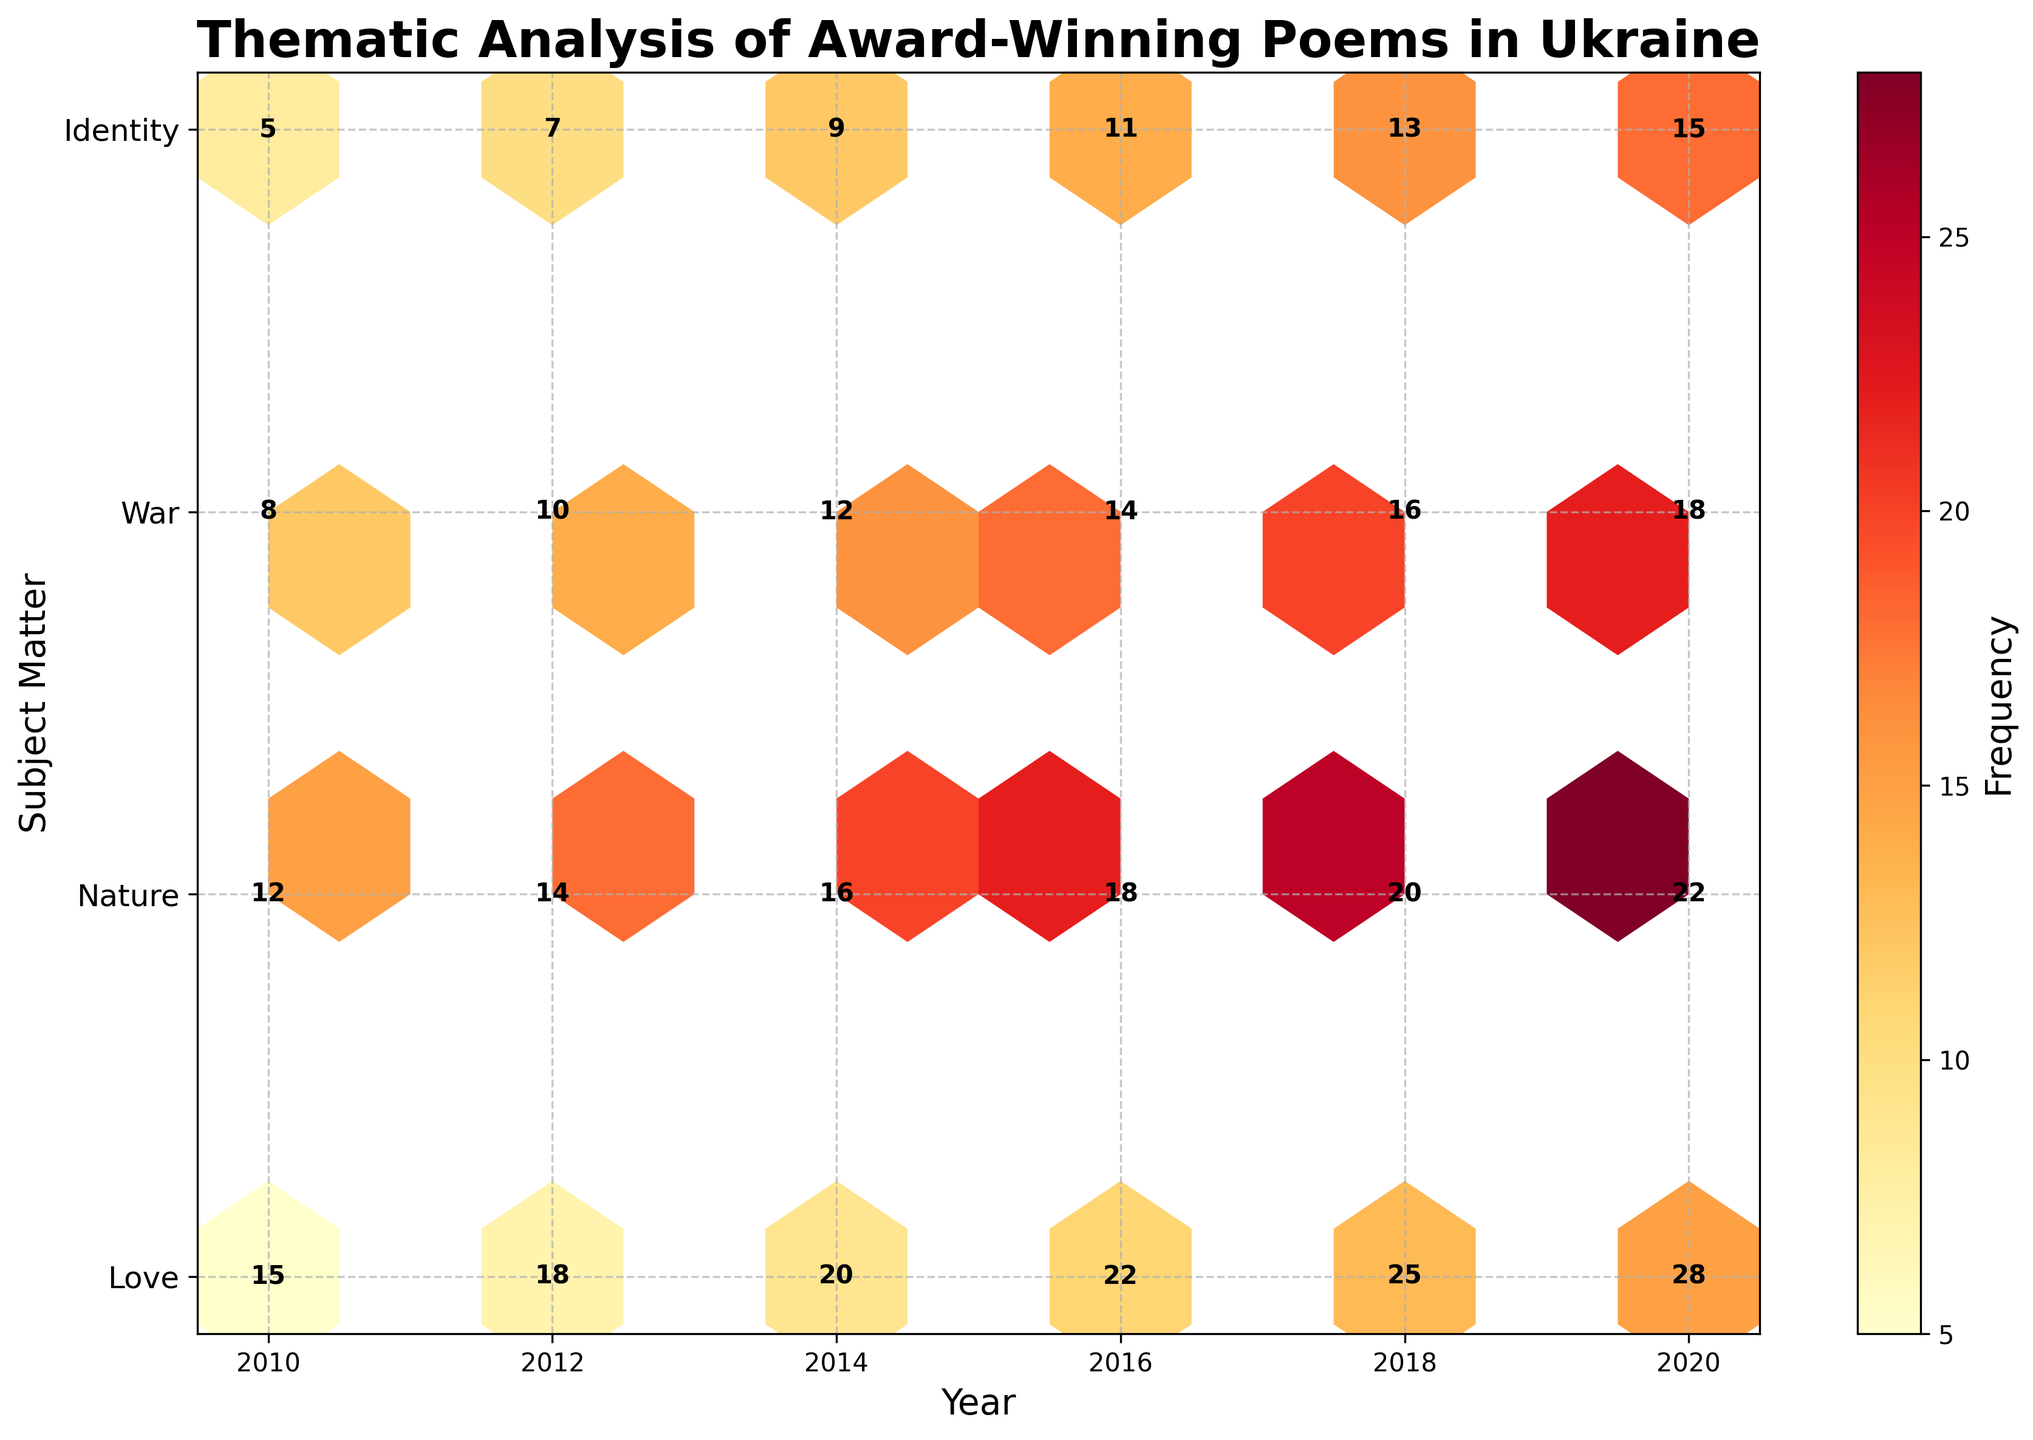What is the title of the plot? The title of the plot can be seen at the top of the figure. It reads "Thematic Analysis of Award-Winning Poems in Ukraine".
Answer: Thematic Analysis of Award-Winning Poems in Ukraine What years are represented on the X-axis? By examining the X-axis, you can see the labels for different years. The plot includes years 2010, 2012, 2014, 2016, 2018, and 2020.
Answer: 2010, 2012, 2014, 2016, 2018, 2020 How is the frequency of each subject indicated? The frequency is indicated by both color intensity and the number annotations on each hexbin. The color ranges from lighter to darker shades of yellow, orange, and red as frequency increases.
Answer: Color intensity and number annotations Which subject had the highest frequency in the year 2020? To find the highest frequency in 2020, look at the year 2020 on the X-axis and check the frequencies annotated in that column. The subject "Love" has the highest frequency of 28 in 2020.
Answer: Love How does the frequency of "Nature" change from 2010 to 2020? By examining the hexbin plot along the row corresponding to "Nature," note the frequencies annotated for each year. The frequencies are 12 (2010), 14 (2012), 16 (2014), 18 (2016), 20 (2018), and 22 (2020). Frequency increases by 2 every 2 years.
Answer: Increases steadily What is the combined frequency of the "War" subject for all the years represented? Summing up the frequencies of "War" for all years: 8 (2010) + 10 (2012) + 12 (2014) + 14 (2016) + 16 (2018) + 18 (2020) = 78.
Answer: 78 Compare the frequency trends of "Love" and "Identity" from 2010 to 2020. Which one sees a steeper increase? The frequencies of "Love" are: 15 (2010), 18 (2012), 20 (2014), 22 (2016), 25 (2018), 28 (2020). For "Identity," the frequencies are: 5 (2010), 7 (2012), 9 (2014), 11 (2016), 13 (2018), 15 (2020). The frequency of "Love" increases by 13 while "Identity" increases by 10. "Love" sees a steeper increase.
Answer: Love Which subject has the least frequent occurrence in 2014? By checking the year 2014, the frequencies are: Love (20), Nature (16), War (12), Identity (9). Identity has the least frequency of 9.
Answer: Identity Is there any year where the frequency of "Identity" surpasses that of "War"? From the plot, examine the frequencies for each year. For all years (2010, 2012, 2014, 2016, 2018, 2020), the frequency of "War" is always higher than "Identity".
Answer: No What is the average frequency of poems about "Nature" across all years? Calculate the mean frequency of "Nature". Frequencies are: 12 (2010), 14 (2012), 16 (2014), 18 (2016), 20 (2018), 22 (2020). Sum = 102, Average = 102/6 = 17.
Answer: 17 